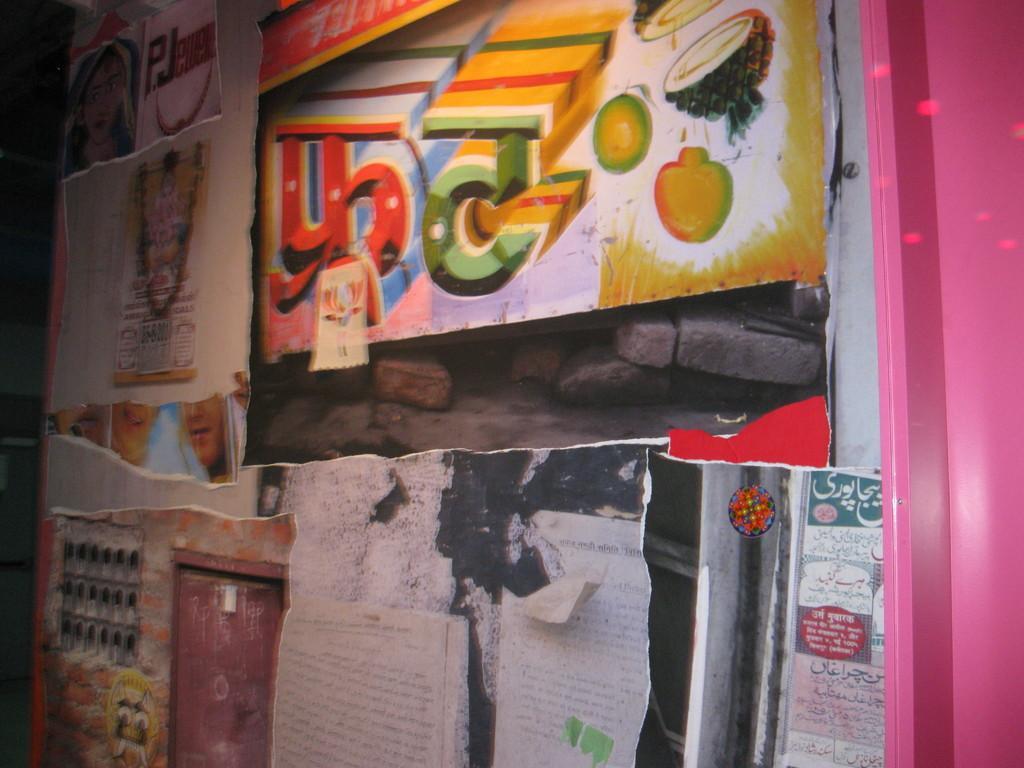How would you summarize this image in a sentence or two? In this image I can see a wall which has posters and papers attached to it. 